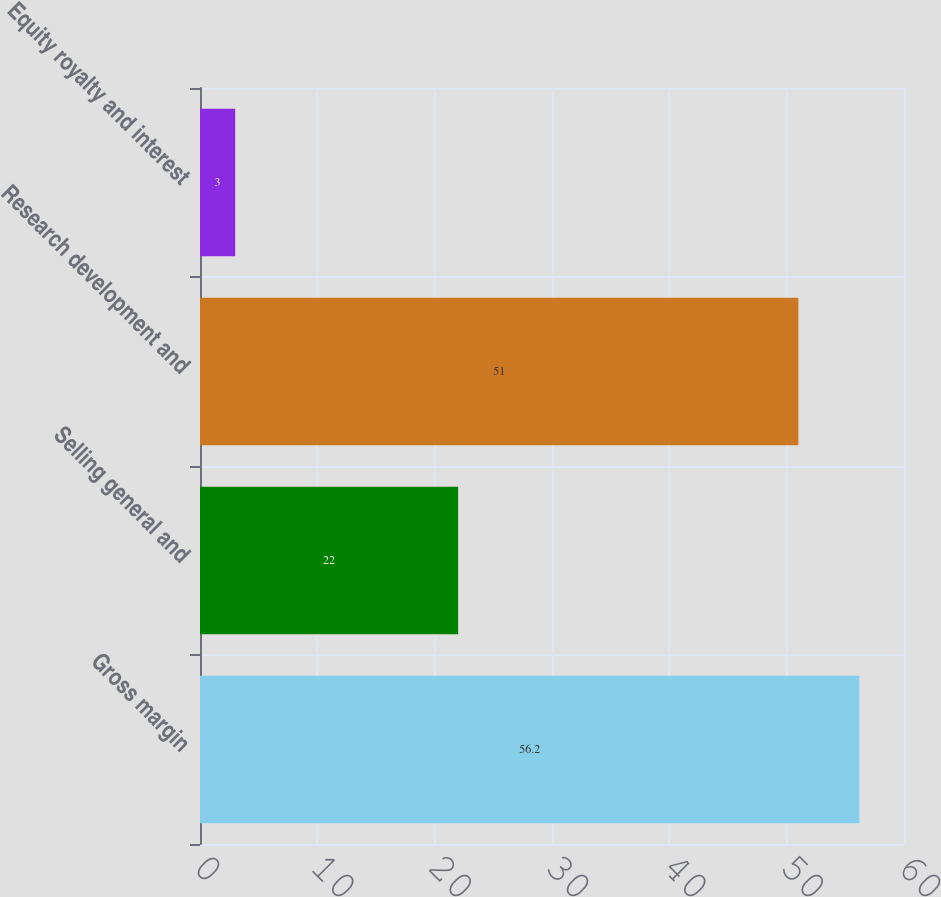Convert chart to OTSL. <chart><loc_0><loc_0><loc_500><loc_500><bar_chart><fcel>Gross margin<fcel>Selling general and<fcel>Research development and<fcel>Equity royalty and interest<nl><fcel>56.2<fcel>22<fcel>51<fcel>3<nl></chart> 